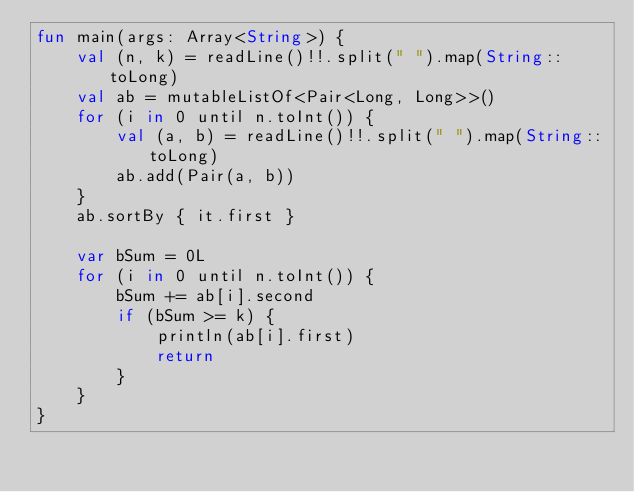Convert code to text. <code><loc_0><loc_0><loc_500><loc_500><_Kotlin_>fun main(args: Array<String>) {
    val (n, k) = readLine()!!.split(" ").map(String::toLong)
    val ab = mutableListOf<Pair<Long, Long>>()
    for (i in 0 until n.toInt()) {
        val (a, b) = readLine()!!.split(" ").map(String::toLong)
        ab.add(Pair(a, b))
    }
    ab.sortBy { it.first }

    var bSum = 0L
    for (i in 0 until n.toInt()) {
        bSum += ab[i].second
        if (bSum >= k) {
            println(ab[i].first)
            return
        }
    }
}
</code> 